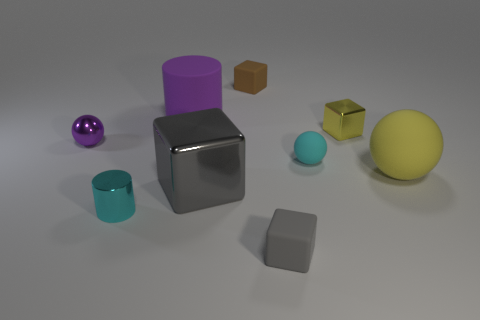There is a purple metal thing that is the same size as the cyan matte object; what shape is it? sphere 